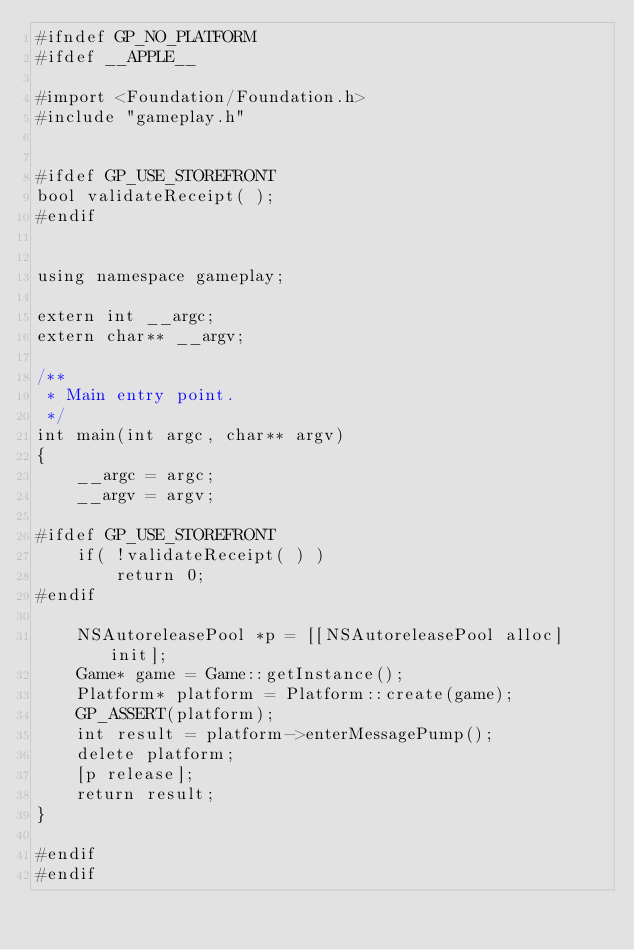<code> <loc_0><loc_0><loc_500><loc_500><_ObjectiveC_>#ifndef GP_NO_PLATFORM
#ifdef __APPLE__

#import <Foundation/Foundation.h>
#include "gameplay.h"


#ifdef GP_USE_STOREFRONT
bool validateReceipt( );
#endif


using namespace gameplay;

extern int __argc;
extern char** __argv;

/**
 * Main entry point.
 */
int main(int argc, char** argv)
{
    __argc = argc;
    __argv = argv;
    
#ifdef GP_USE_STOREFRONT
    if( !validateReceipt( ) )
        return 0;
#endif
    
    NSAutoreleasePool *p = [[NSAutoreleasePool alloc] init];
    Game* game = Game::getInstance();
    Platform* platform = Platform::create(game);
    GP_ASSERT(platform);
    int result = platform->enterMessagePump();
    delete platform;
    [p release];
    return result;
}

#endif
#endif</code> 